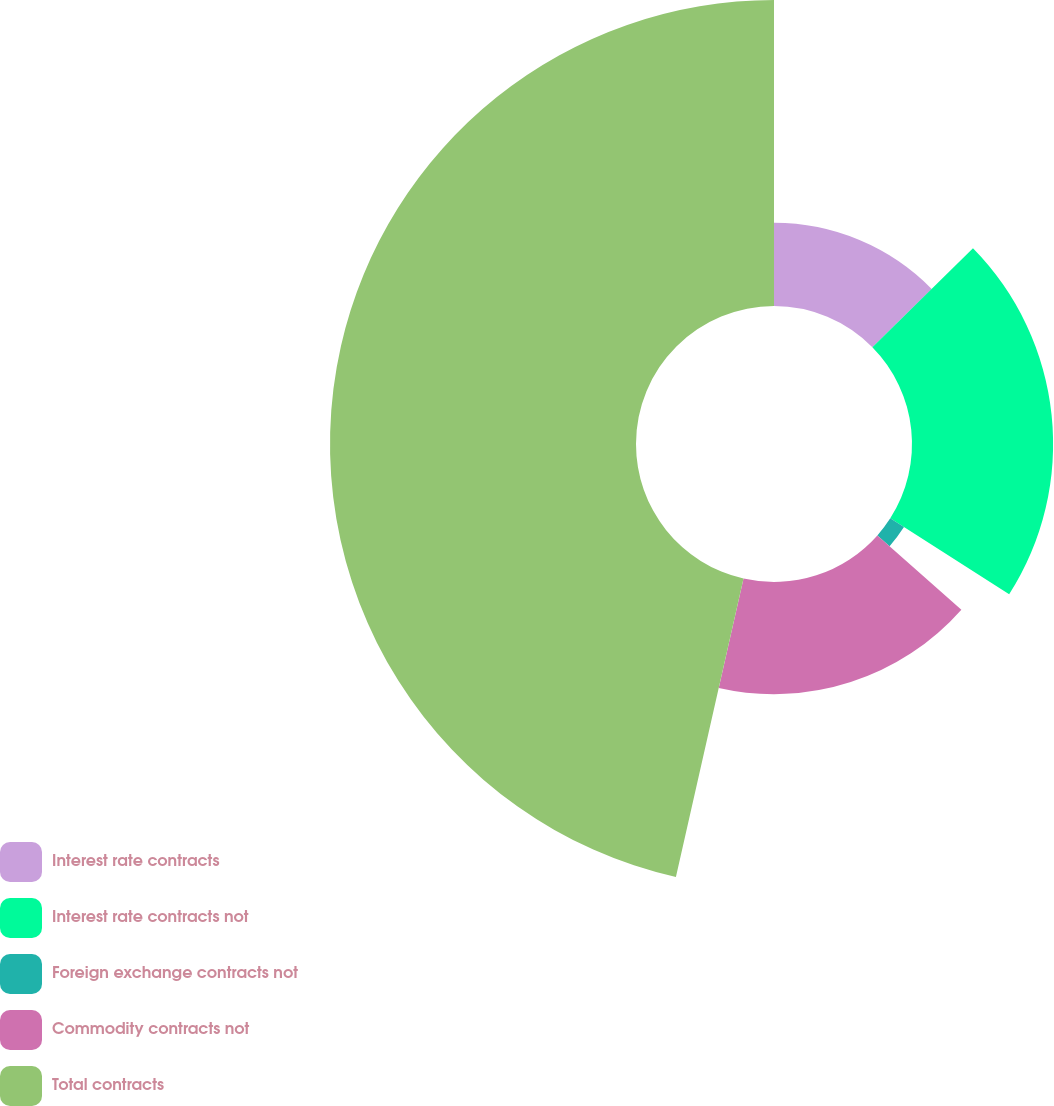Convert chart to OTSL. <chart><loc_0><loc_0><loc_500><loc_500><pie_chart><fcel>Interest rate contracts<fcel>Interest rate contracts not<fcel>Foreign exchange contracts not<fcel>Commodity contracts not<fcel>Total contracts<nl><fcel>12.63%<fcel>21.42%<fcel>2.47%<fcel>17.02%<fcel>46.45%<nl></chart> 